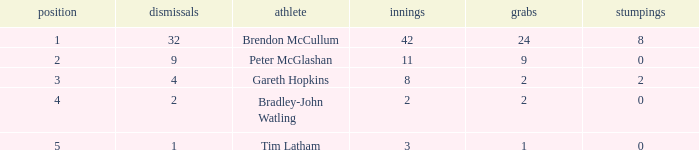How many innings had a total of 2 catches and 0 stumpings? 1.0. 